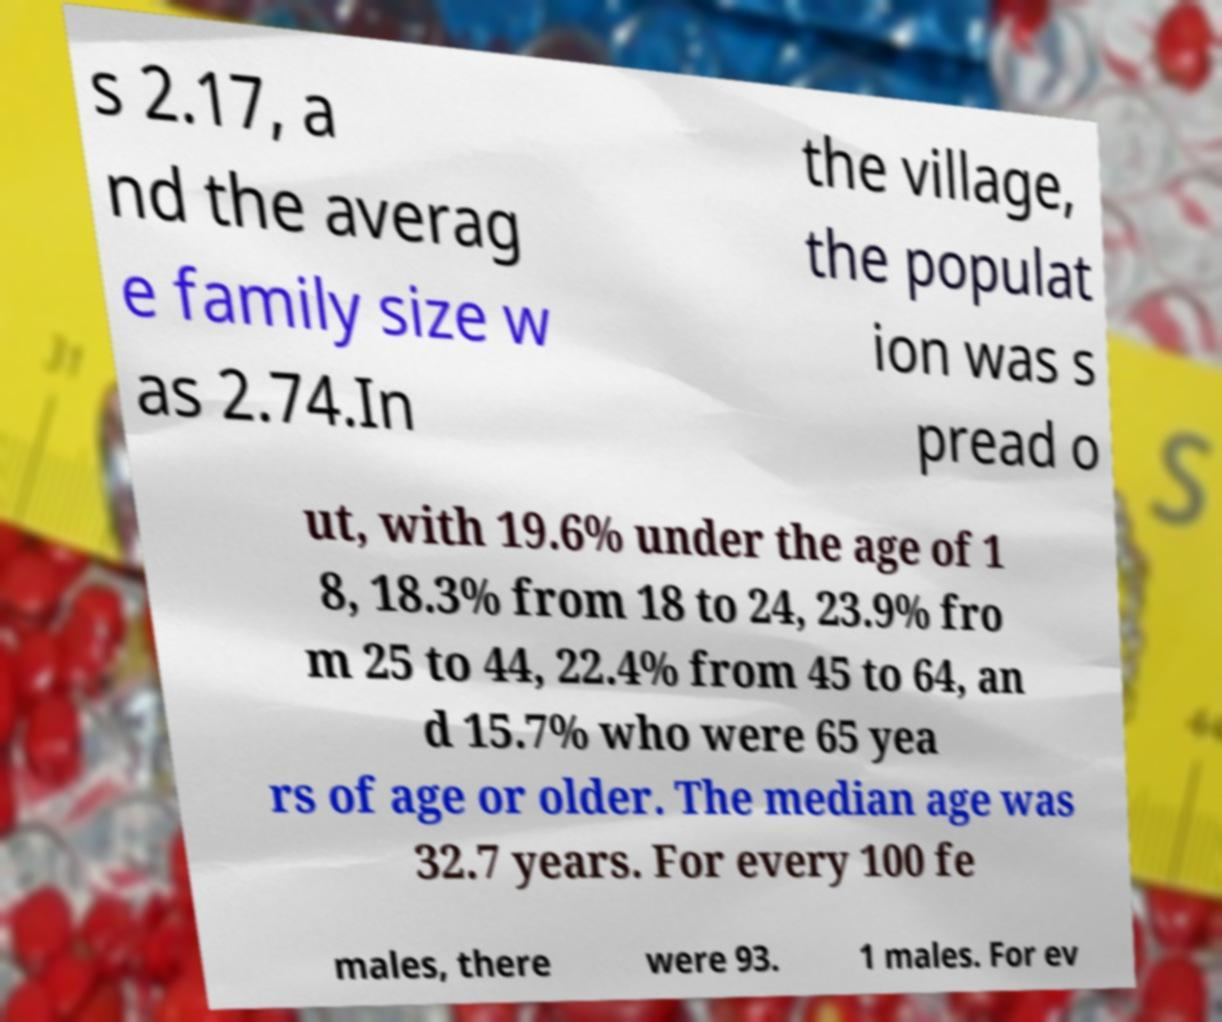For documentation purposes, I need the text within this image transcribed. Could you provide that? s 2.17, a nd the averag e family size w as 2.74.In the village, the populat ion was s pread o ut, with 19.6% under the age of 1 8, 18.3% from 18 to 24, 23.9% fro m 25 to 44, 22.4% from 45 to 64, an d 15.7% who were 65 yea rs of age or older. The median age was 32.7 years. For every 100 fe males, there were 93. 1 males. For ev 